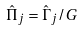<formula> <loc_0><loc_0><loc_500><loc_500>\hat { \Pi } _ { j } = \hat { \Gamma } _ { j } / G</formula> 